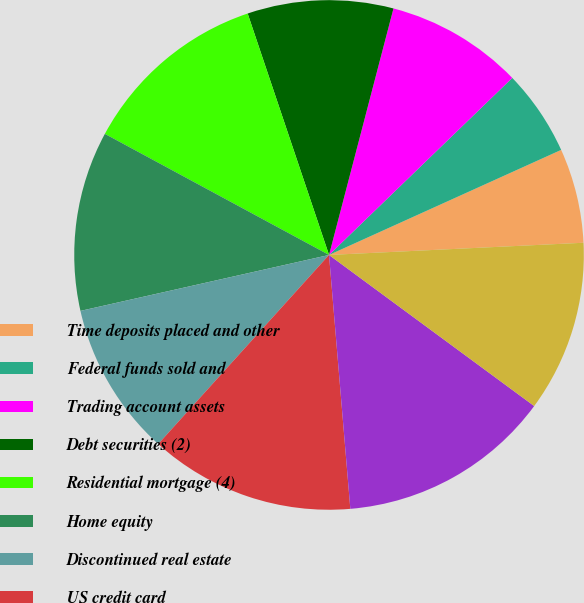<chart> <loc_0><loc_0><loc_500><loc_500><pie_chart><fcel>Time deposits placed and other<fcel>Federal funds sold and<fcel>Trading account assets<fcel>Debt securities (2)<fcel>Residential mortgage (4)<fcel>Home equity<fcel>Discontinued real estate<fcel>US credit card<fcel>Non-US credit card<fcel>Direct/Indirect consumer (5)<nl><fcel>6.0%<fcel>5.46%<fcel>8.7%<fcel>9.24%<fcel>11.94%<fcel>11.4%<fcel>9.78%<fcel>13.02%<fcel>13.56%<fcel>10.86%<nl></chart> 